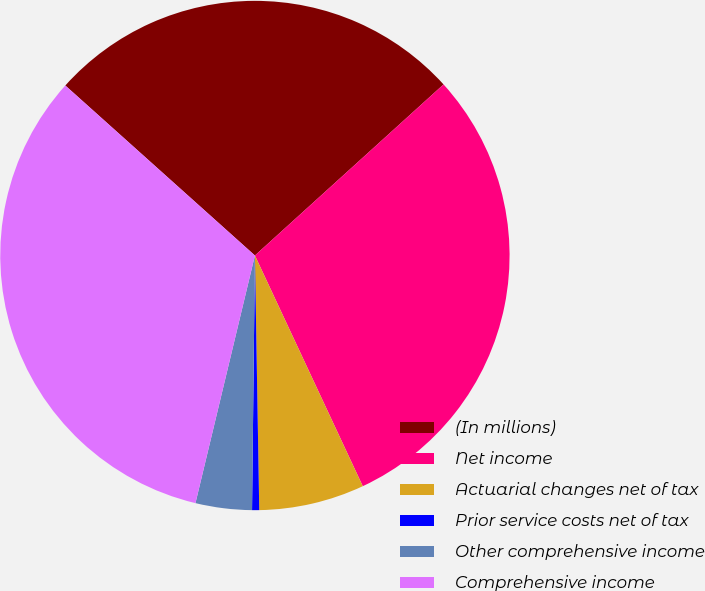Convert chart. <chart><loc_0><loc_0><loc_500><loc_500><pie_chart><fcel>(In millions)<fcel>Net income<fcel>Actuarial changes net of tax<fcel>Prior service costs net of tax<fcel>Other comprehensive income<fcel>Comprehensive income<nl><fcel>26.64%<fcel>29.76%<fcel>6.69%<fcel>0.45%<fcel>3.57%<fcel>32.88%<nl></chart> 